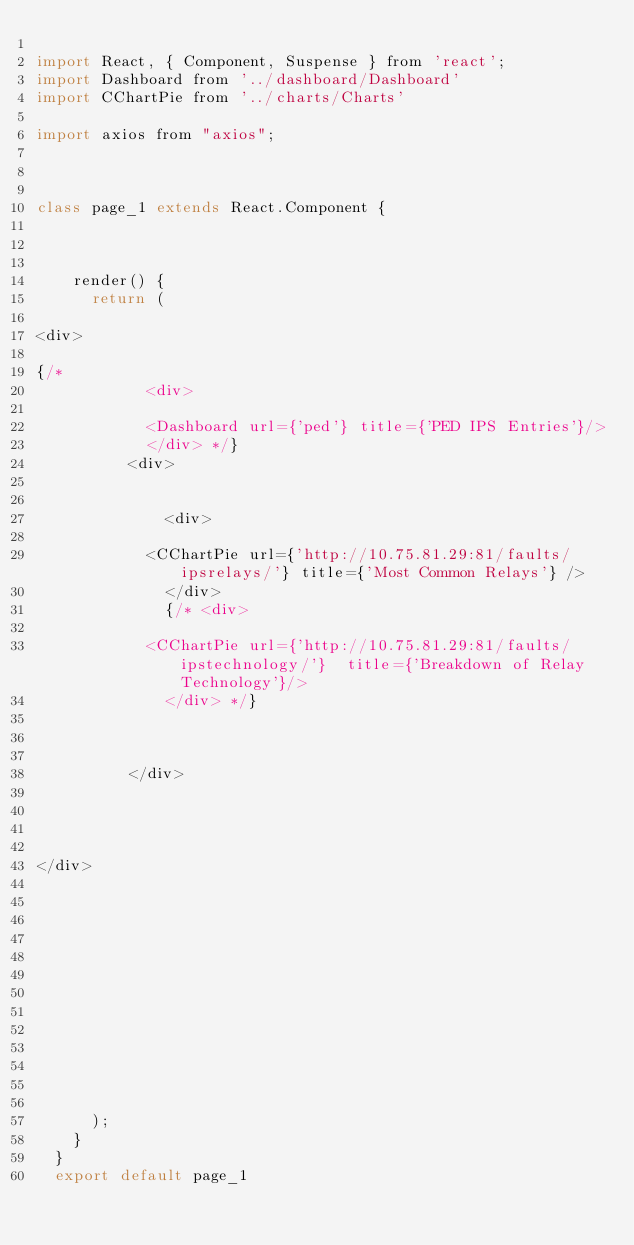Convert code to text. <code><loc_0><loc_0><loc_500><loc_500><_JavaScript_>
import React, { Component, Suspense } from 'react';
import Dashboard from '../dashboard/Dashboard'
import CChartPie from '../charts/Charts'

import axios from "axios";



class page_1 extends React.Component {

  

    render() {
      return (
        
<div>

{/* 
            <div>

            <Dashboard url={'ped'} title={'PED IPS Entries'}/> 
            </div> */}
          <div>

            
              <div>

            <CChartPie url={'http://10.75.81.29:81/faults/ipsrelays/'} title={'Most Common Relays'} />
              </div>
              {/* <div>

            <CChartPie url={'http://10.75.81.29:81/faults/ipstechnology/'}  title={'Breakdown of Relay Technology'}/>
              </div> */}
            

            
          </div>
         
            
          

</div>
  


     
  

      
        

        
      
     

      );
    }
  }
  export default page_1</code> 